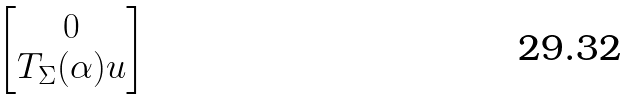<formula> <loc_0><loc_0><loc_500><loc_500>\begin{bmatrix} 0 \\ T _ { \Sigma } ( \alpha ) u \end{bmatrix}</formula> 